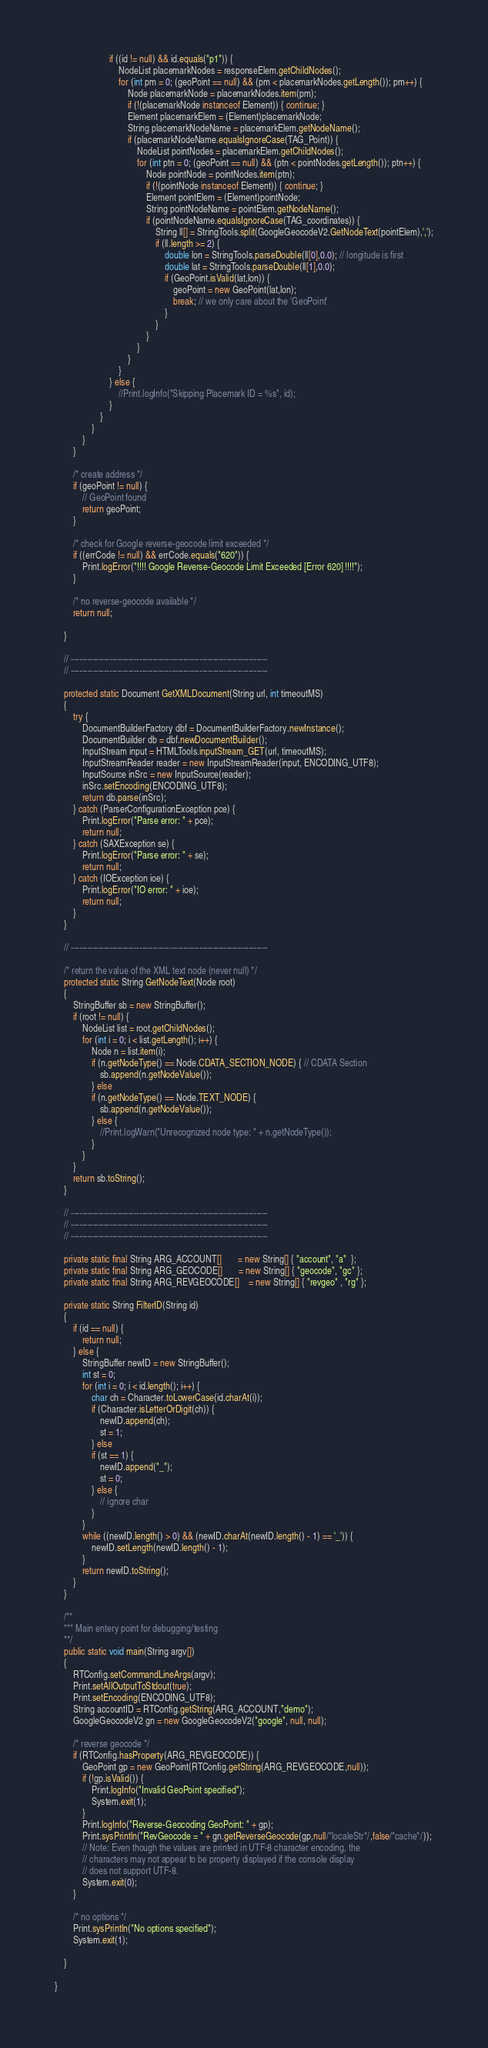Convert code to text. <code><loc_0><loc_0><loc_500><loc_500><_Java_>                        if ((id != null) && id.equals("p1")) {
                            NodeList placemarkNodes = responseElem.getChildNodes();
                            for (int pm = 0; (geoPoint == null) && (pm < placemarkNodes.getLength()); pm++) {
                                Node placemarkNode = placemarkNodes.item(pm);
                                if (!(placemarkNode instanceof Element)) { continue; }
                                Element placemarkElem = (Element)placemarkNode;
                                String placemarkNodeName = placemarkElem.getNodeName();
                                if (placemarkNodeName.equalsIgnoreCase(TAG_Point)) {
                                    NodeList pointNodes = placemarkElem.getChildNodes();
                                    for (int ptn = 0; (geoPoint == null) && (ptn < pointNodes.getLength()); ptn++) {
                                        Node pointNode = pointNodes.item(ptn);
                                        if (!(pointNode instanceof Element)) { continue; }
                                        Element pointElem = (Element)pointNode;
                                        String pointNodeName = pointElem.getNodeName();
                                        if (pointNodeName.equalsIgnoreCase(TAG_coordinates)) {
                                            String ll[] = StringTools.split(GoogleGeocodeV2.GetNodeText(pointElem),',');
                                            if (ll.length >= 2) {
                                                double lon = StringTools.parseDouble(ll[0],0.0); // longitude is first
                                                double lat = StringTools.parseDouble(ll[1],0.0); 
                                                if (GeoPoint.isValid(lat,lon)) {
                                                    geoPoint = new GeoPoint(lat,lon);
                                                    break; // we only care about the 'GeoPoint'
                                                }
                                            }
                                        }
                                    }                                    
                                }
                            }
                        } else {
                            //Print.logInfo("Skipping Placemark ID = %s", id);
                        }
                    }
                }
            }
        }

        /* create address */
        if (geoPoint != null) {
            // GeoPoint found 
            return geoPoint;
        }
        
        /* check for Google reverse-geocode limit exceeded */
        if ((errCode != null) && errCode.equals("620")) {
            Print.logError("!!!! Google Reverse-Geocode Limit Exceeded [Error 620] !!!!");
        }

        /* no reverse-geocode available */
        return null;

    }

    // ------------------------------------------------------------------------
    // ------------------------------------------------------------------------

    protected static Document GetXMLDocument(String url, int timeoutMS)
    {
        try {
            DocumentBuilderFactory dbf = DocumentBuilderFactory.newInstance();
            DocumentBuilder db = dbf.newDocumentBuilder();
            InputStream input = HTMLTools.inputStream_GET(url, timeoutMS);
            InputStreamReader reader = new InputStreamReader(input, ENCODING_UTF8);
            InputSource inSrc = new InputSource(reader);
            inSrc.setEncoding(ENCODING_UTF8);
            return db.parse(inSrc);
        } catch (ParserConfigurationException pce) {
            Print.logError("Parse error: " + pce);
            return null;
        } catch (SAXException se) {
            Print.logError("Parse error: " + se);
            return null;
        } catch (IOException ioe) {
            Print.logError("IO error: " + ioe);
            return null;
        }
    }

    // ------------------------------------------------------------------------

    /* return the value of the XML text node (never null) */
    protected static String GetNodeText(Node root)
    {
        StringBuffer sb = new StringBuffer();
        if (root != null) {
            NodeList list = root.getChildNodes();
            for (int i = 0; i < list.getLength(); i++) {
                Node n = list.item(i);
                if (n.getNodeType() == Node.CDATA_SECTION_NODE) { // CDATA Section
                    sb.append(n.getNodeValue());
                } else
                if (n.getNodeType() == Node.TEXT_NODE) {
                    sb.append(n.getNodeValue());
                } else {
                    //Print.logWarn("Unrecognized node type: " + n.getNodeType());
                }
            }
        }
        return sb.toString();
    }

    // ------------------------------------------------------------------------
    // ------------------------------------------------------------------------
    // ------------------------------------------------------------------------
    
    private static final String ARG_ACCOUNT[]       = new String[] { "account", "a"  };
    private static final String ARG_GEOCODE[]       = new String[] { "geocode", "gc" };
    private static final String ARG_REVGEOCODE[]    = new String[] { "revgeo" , "rg" };
    
    private static String FilterID(String id)
    {
        if (id == null) {
            return null;
        } else {
            StringBuffer newID = new StringBuffer();
            int st = 0;
            for (int i = 0; i < id.length(); i++) {
                char ch = Character.toLowerCase(id.charAt(i));
                if (Character.isLetterOrDigit(ch)) {
                    newID.append(ch);
                    st = 1;
                } else
                if (st == 1) {
                    newID.append("_");
                    st = 0;
                } else {
                    // ignore char
                }
            }
            while ((newID.length() > 0) && (newID.charAt(newID.length() - 1) == '_')) {
                newID.setLength(newID.length() - 1);
            }
            return newID.toString();
        }
    }

    /**
    *** Main entery point for debugging/testing
    **/
    public static void main(String argv[])
    {
        RTConfig.setCommandLineArgs(argv);
        Print.setAllOutputToStdout(true);
        Print.setEncoding(ENCODING_UTF8);
        String accountID = RTConfig.getString(ARG_ACCOUNT,"demo");
        GoogleGeocodeV2 gn = new GoogleGeocodeV2("google", null, null);

        /* reverse geocode */
        if (RTConfig.hasProperty(ARG_REVGEOCODE)) {
            GeoPoint gp = new GeoPoint(RTConfig.getString(ARG_REVGEOCODE,null));
            if (!gp.isValid()) {
                Print.logInfo("Invalid GeoPoint specified");
                System.exit(1);
            }
            Print.logInfo("Reverse-Geocoding GeoPoint: " + gp);
            Print.sysPrintln("RevGeocode = " + gn.getReverseGeocode(gp,null/*localeStr*/,false/*cache*/));
            // Note: Even though the values are printed in UTF-8 character encoding, the
            // characters may not appear to be property displayed if the console display
            // does not support UTF-8.
            System.exit(0);
        }

        /* no options */
        Print.sysPrintln("No options specified");
        System.exit(1);

    }

}
</code> 